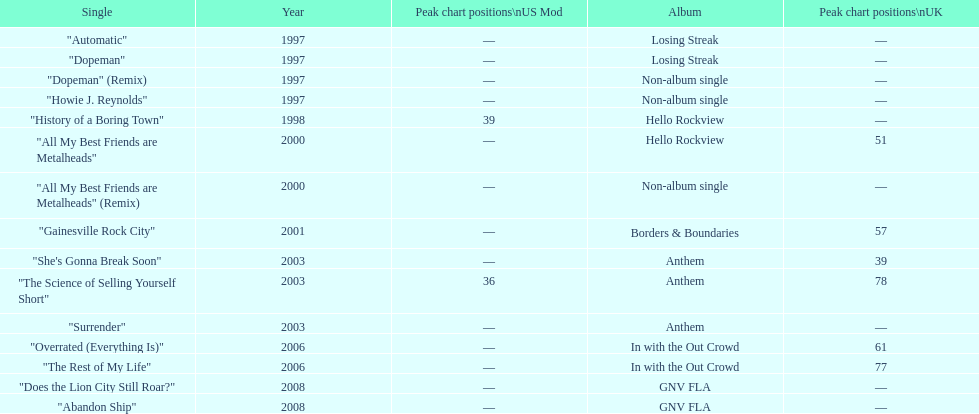In which album was the single "automatic" featured? Losing Streak. 